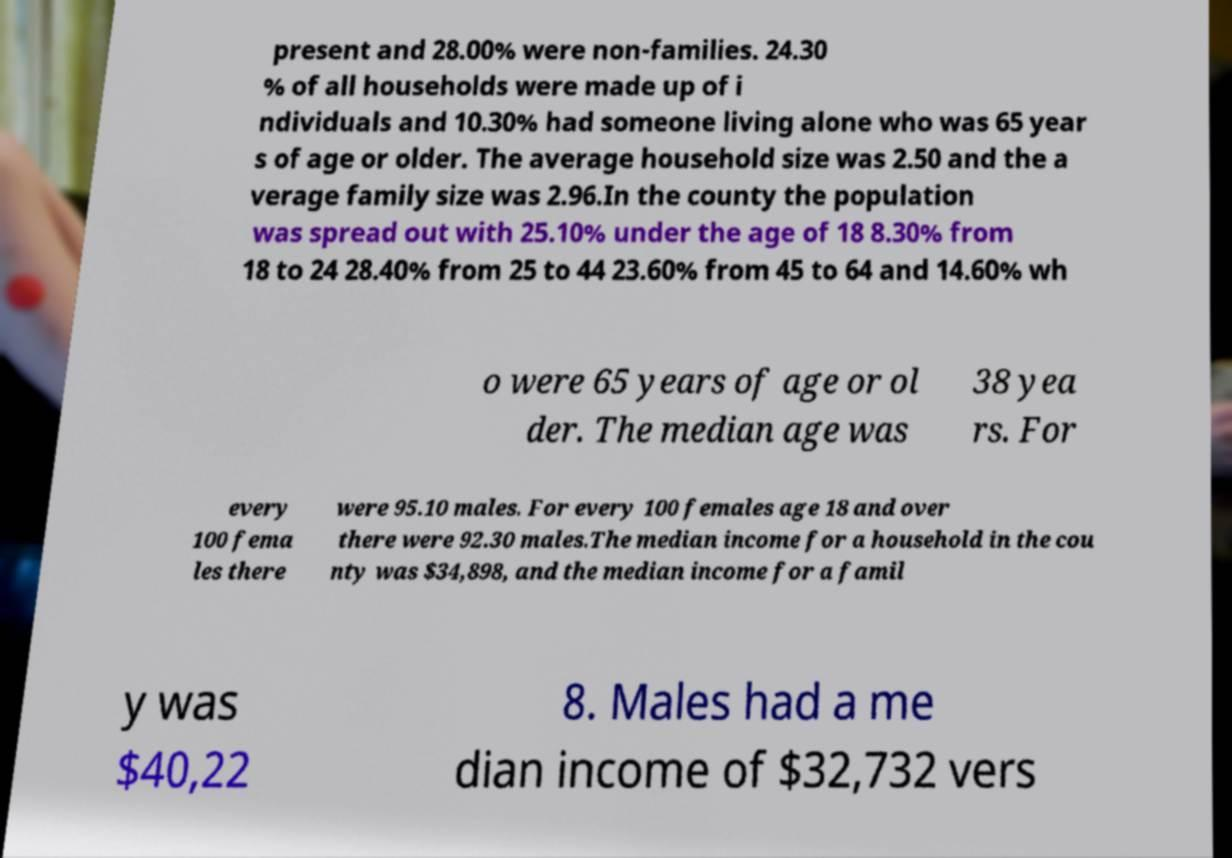Could you extract and type out the text from this image? present and 28.00% were non-families. 24.30 % of all households were made up of i ndividuals and 10.30% had someone living alone who was 65 year s of age or older. The average household size was 2.50 and the a verage family size was 2.96.In the county the population was spread out with 25.10% under the age of 18 8.30% from 18 to 24 28.40% from 25 to 44 23.60% from 45 to 64 and 14.60% wh o were 65 years of age or ol der. The median age was 38 yea rs. For every 100 fema les there were 95.10 males. For every 100 females age 18 and over there were 92.30 males.The median income for a household in the cou nty was $34,898, and the median income for a famil y was $40,22 8. Males had a me dian income of $32,732 vers 